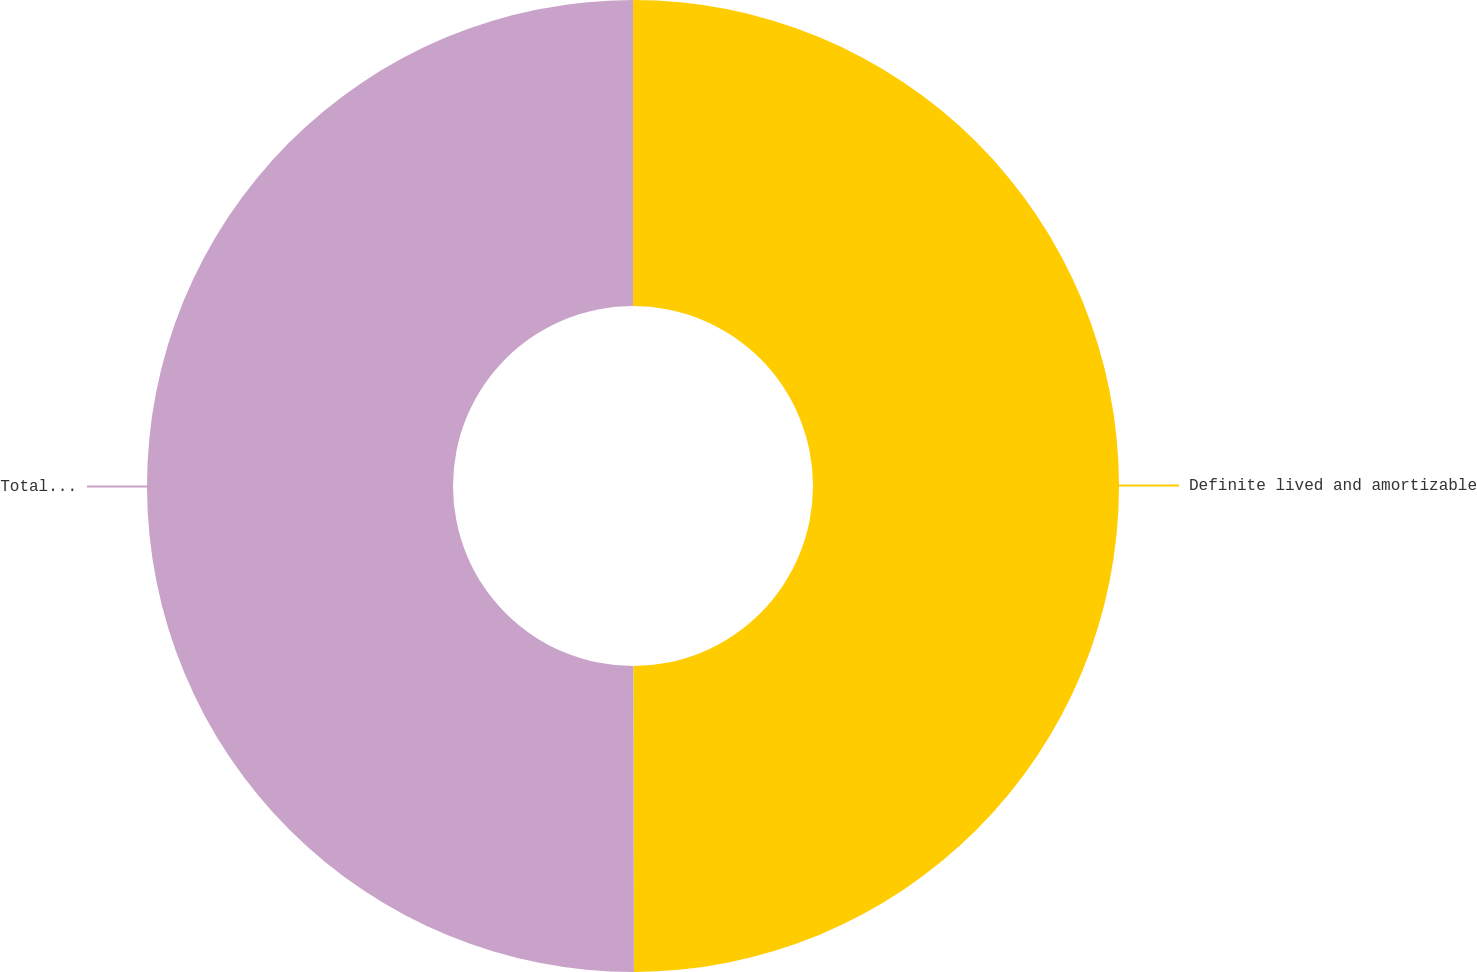Convert chart. <chart><loc_0><loc_0><loc_500><loc_500><pie_chart><fcel>Definite lived and amortizable<fcel>Total acquired intangible<nl><fcel>49.97%<fcel>50.03%<nl></chart> 